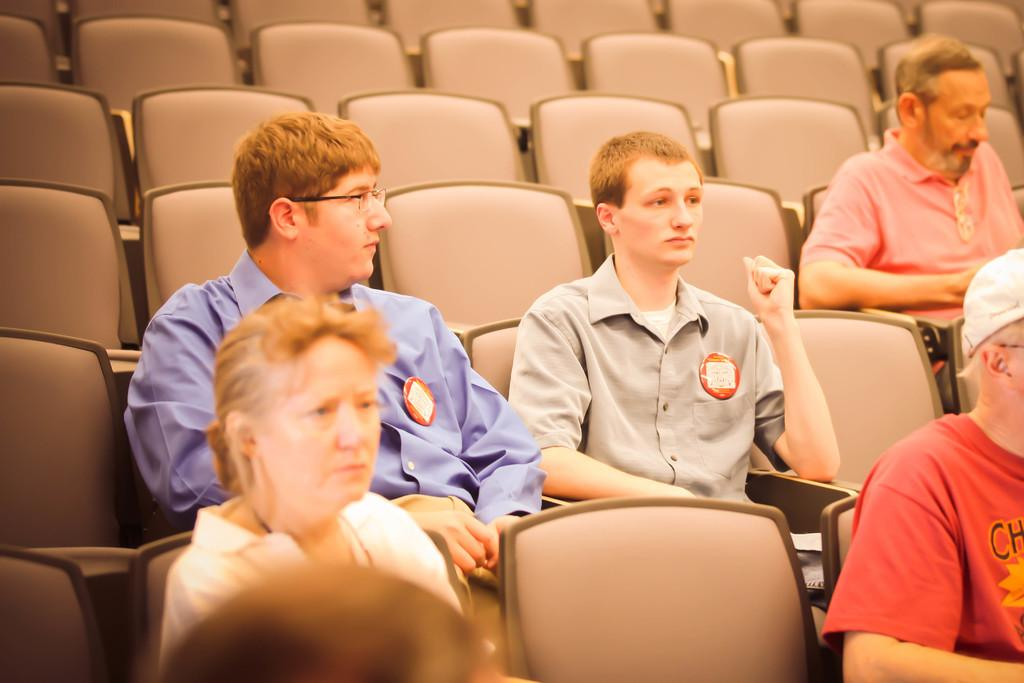What are the people in the image doing? The people in the image are sitting on chairs. Can you describe the appearance of one of the people in the image? A person is wearing a cap on the right side of the image. What can be seen in the background of the image? Chairs are visible in the background of the image. What type of blade is being used by the person on the left side of the image? There is no blade present in the image; people are sitting on chairs. Can you describe the speed of the snail in the image? There is no snail present in the image; it is a scene of people sitting on chairs. 